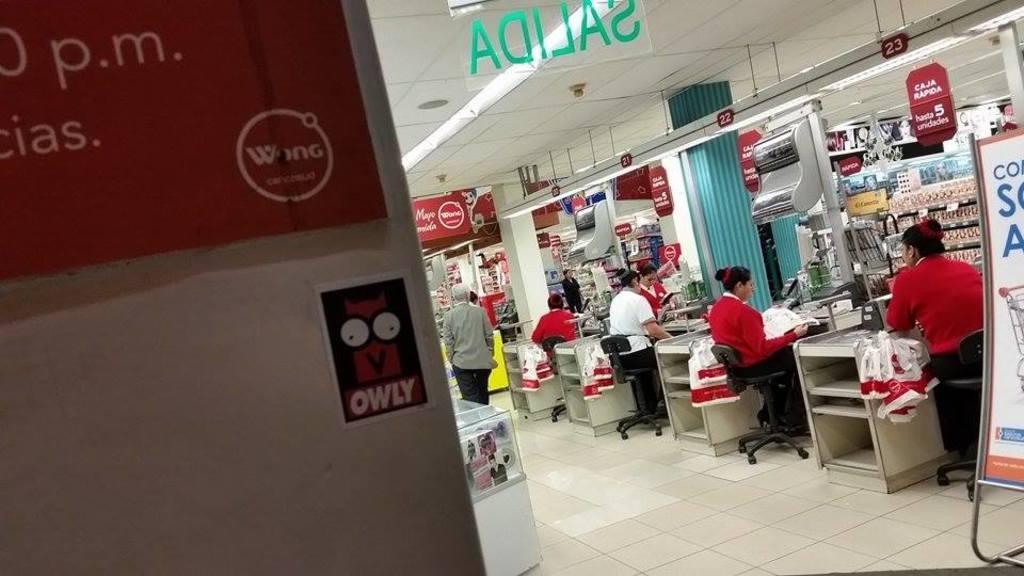In one or two sentences, can you explain what this image depicts? In this image I see people image, in which few of them are standing and few of them are sitting, I can also see there are tables in front of them. In the background I see boards, groceries in the racks. 